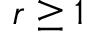<formula> <loc_0><loc_0><loc_500><loc_500>r \geq 1</formula> 